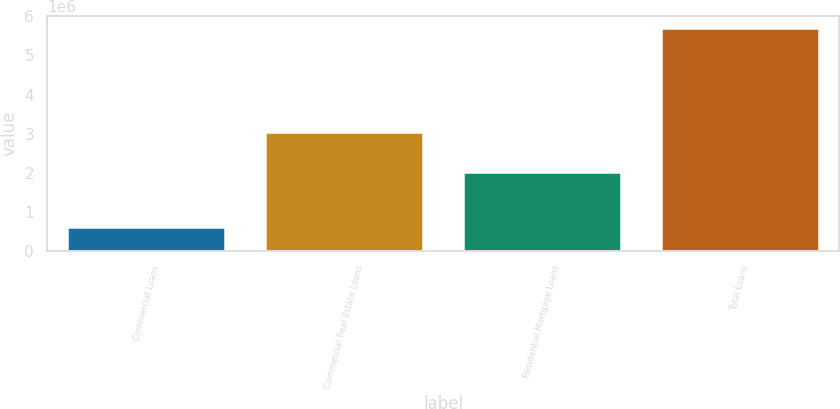<chart> <loc_0><loc_0><loc_500><loc_500><bar_chart><fcel>Commercial Loans<fcel>Commercial Real Estate Loans<fcel>Residential Mortgage Loans<fcel>Total Loans<nl><fcel>603708<fcel>3.04766e+06<fcel>2.01699e+06<fcel>5.71676e+06<nl></chart> 